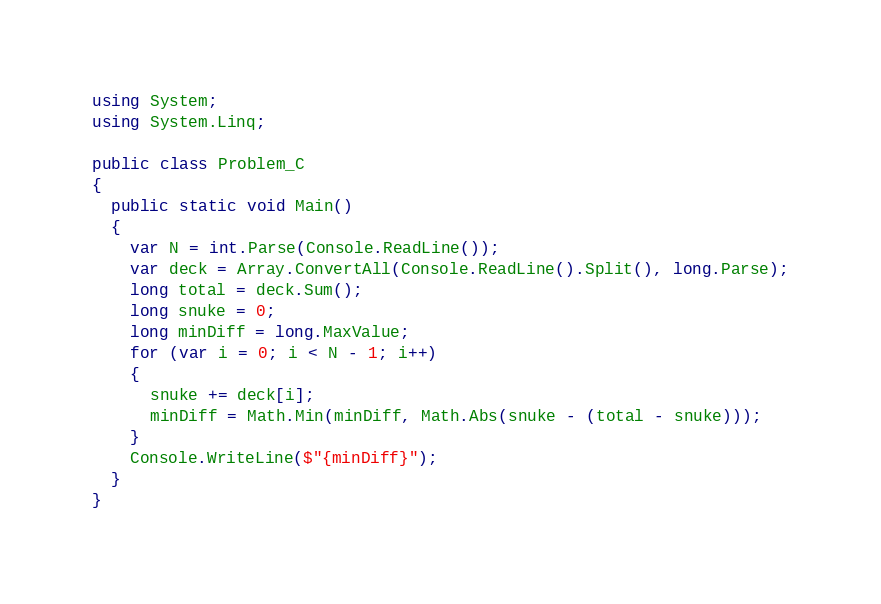Convert code to text. <code><loc_0><loc_0><loc_500><loc_500><_C#_>using System;
using System.Linq;

public class Problem_C
{
  public static void Main()
  {
    var N = int.Parse(Console.ReadLine());
    var deck = Array.ConvertAll(Console.ReadLine().Split(), long.Parse);
    long total = deck.Sum();
    long snuke = 0;
    long minDiff = long.MaxValue;
    for (var i = 0; i < N - 1; i++)
    {
      snuke += deck[i];
      minDiff = Math.Min(minDiff, Math.Abs(snuke - (total - snuke)));
    }
    Console.WriteLine($"{minDiff}");
  }
}
</code> 